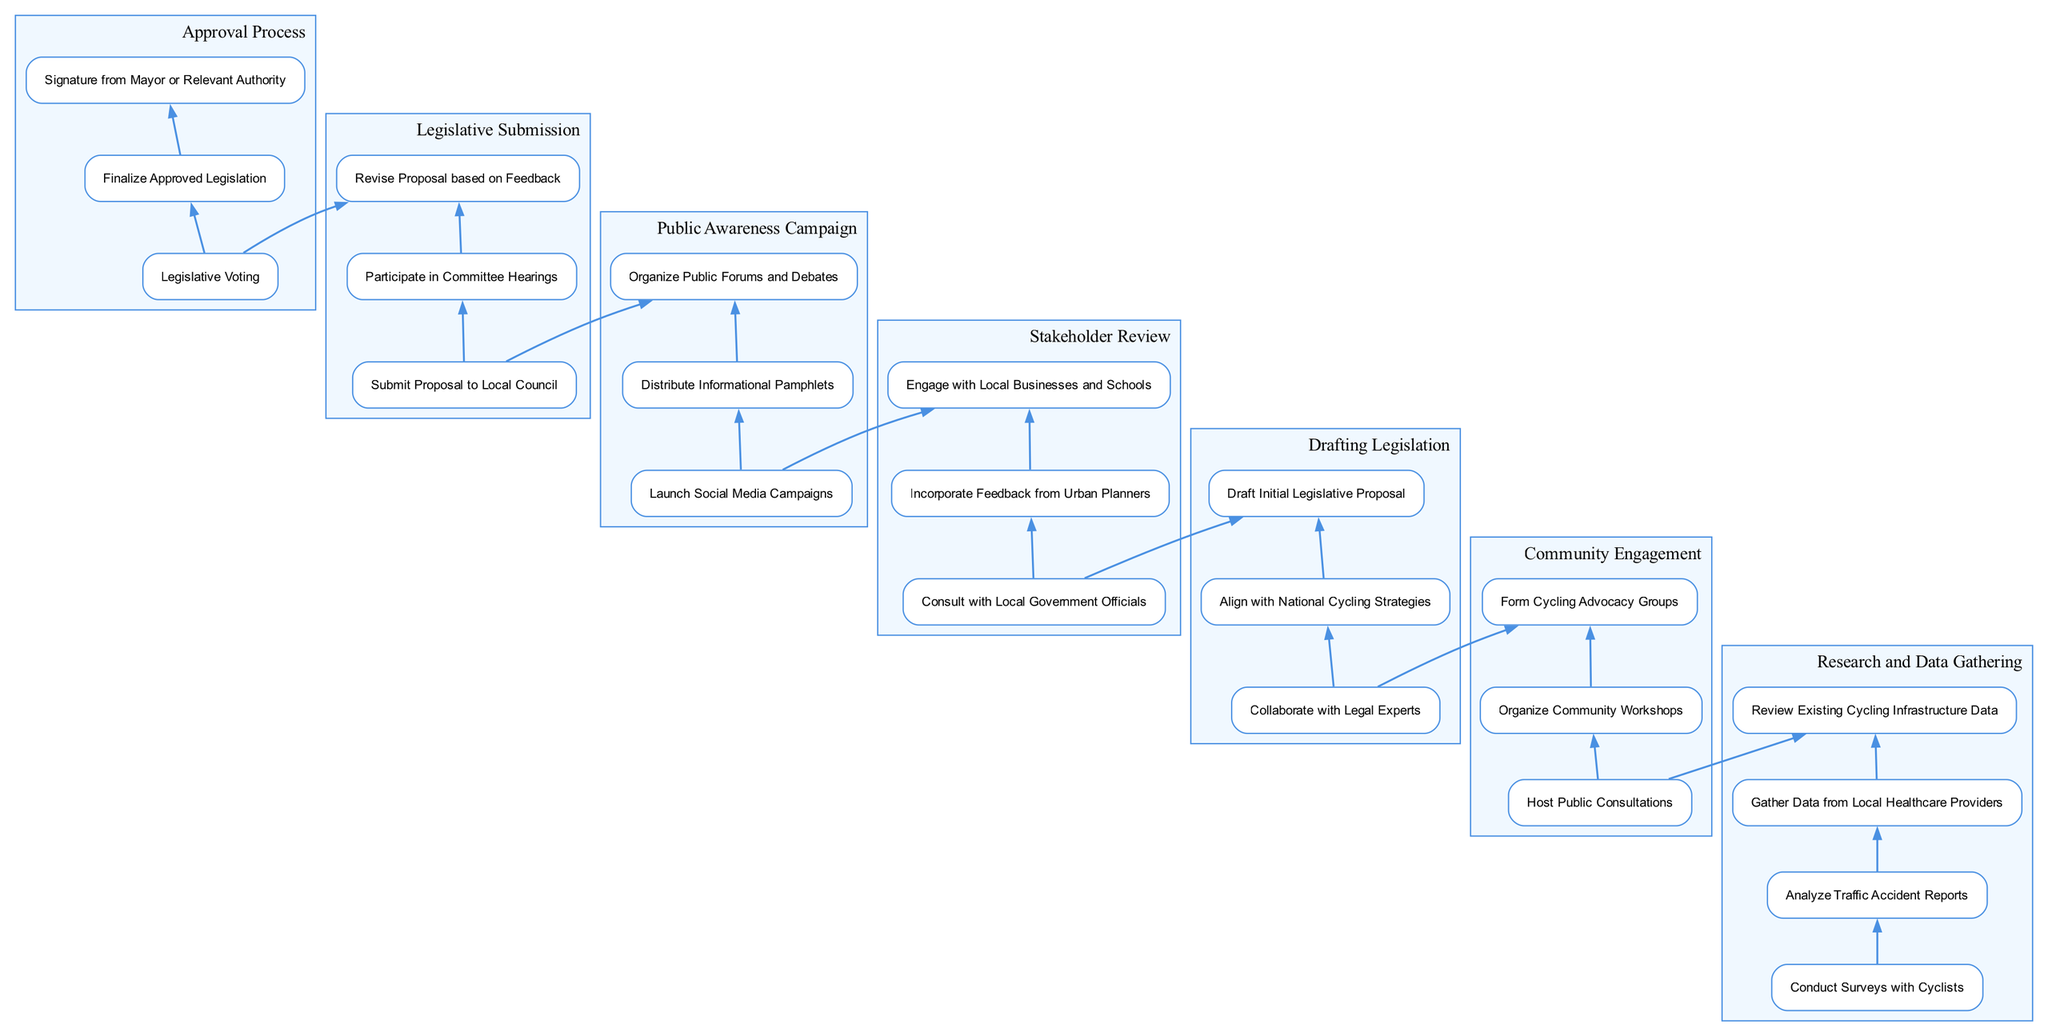What is the first step in the flow chart? The first step in the flow chart is identified at the bottom, labeled "Research and Data Gathering," which is the starting point of the process.
Answer: Research and Data Gathering How many steps are there in the "Community Engagement" section? There are three steps listed in the "Community Engagement" section, which include "Host Public Consultations," "Organize Community Workshops," and "Form Cycling Advocacy Groups."
Answer: 3 What connects "Drafting Legislation" to "Stakeholder Review"? The connection between "Drafting Legislation" and "Stakeholder Review" is established by an edge, indicating that after drafting, the process continues to stakeholder review, suggesting it is the next logical step.
Answer: An edge Which step comes after "Public Awareness Campaign"? "Legislative Submission" follows "Public Awareness Campaign," as indicated by the upward flow in the diagram, showing the sequence of steps towards legislative approval.
Answer: Legislative Submission What is the last step in the approval process? The last step in the approval process, located at the top of the flow chart, is identified as "Signature from Mayor or Relevant Authority," signifying the finalization of the legislation.
Answer: Signature from Mayor or Relevant Authority How many total steps are included in the "Approval Process"? The "Approval Process" consists of three distinct steps: "Legislative Voting," "Finalize Approved Legislation," and "Signature from Mayor or Relevant Authority," indicating the different phases of final approval.
Answer: 3 Which step involves engaging local businesses and schools? The step that involves engaging local businesses and schools is "Stakeholder Review," which specifically mentions consulting various stakeholders, including businesses and schools.
Answer: Stakeholder Review What is the relationship between "Legislative Submission" and "Approval Process"? The relationship is that "Legislative Submission" is a precursor to the "Approval Process," meaning that submission of the proposal leads into the various steps that comprise the approval process.
Answer: Precursor 